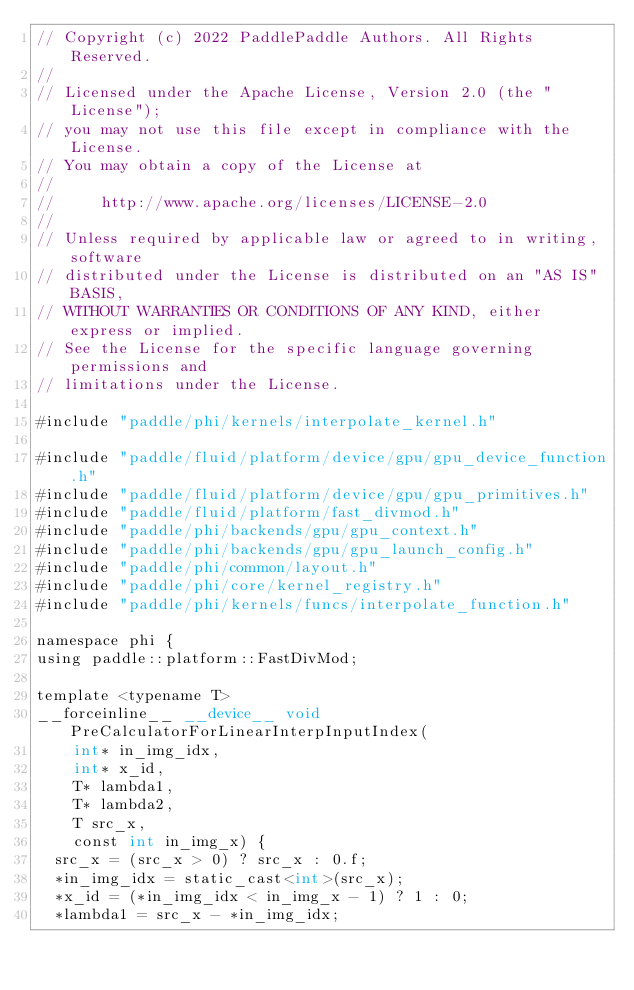Convert code to text. <code><loc_0><loc_0><loc_500><loc_500><_Cuda_>// Copyright (c) 2022 PaddlePaddle Authors. All Rights Reserved.
//
// Licensed under the Apache License, Version 2.0 (the "License");
// you may not use this file except in compliance with the License.
// You may obtain a copy of the License at
//
//     http://www.apache.org/licenses/LICENSE-2.0
//
// Unless required by applicable law or agreed to in writing, software
// distributed under the License is distributed on an "AS IS" BASIS,
// WITHOUT WARRANTIES OR CONDITIONS OF ANY KIND, either express or implied.
// See the License for the specific language governing permissions and
// limitations under the License.

#include "paddle/phi/kernels/interpolate_kernel.h"

#include "paddle/fluid/platform/device/gpu/gpu_device_function.h"
#include "paddle/fluid/platform/device/gpu/gpu_primitives.h"
#include "paddle/fluid/platform/fast_divmod.h"
#include "paddle/phi/backends/gpu/gpu_context.h"
#include "paddle/phi/backends/gpu/gpu_launch_config.h"
#include "paddle/phi/common/layout.h"
#include "paddle/phi/core/kernel_registry.h"
#include "paddle/phi/kernels/funcs/interpolate_function.h"

namespace phi {
using paddle::platform::FastDivMod;

template <typename T>
__forceinline__ __device__ void PreCalculatorForLinearInterpInputIndex(
    int* in_img_idx,
    int* x_id,
    T* lambda1,
    T* lambda2,
    T src_x,
    const int in_img_x) {
  src_x = (src_x > 0) ? src_x : 0.f;
  *in_img_idx = static_cast<int>(src_x);
  *x_id = (*in_img_idx < in_img_x - 1) ? 1 : 0;
  *lambda1 = src_x - *in_img_idx;</code> 